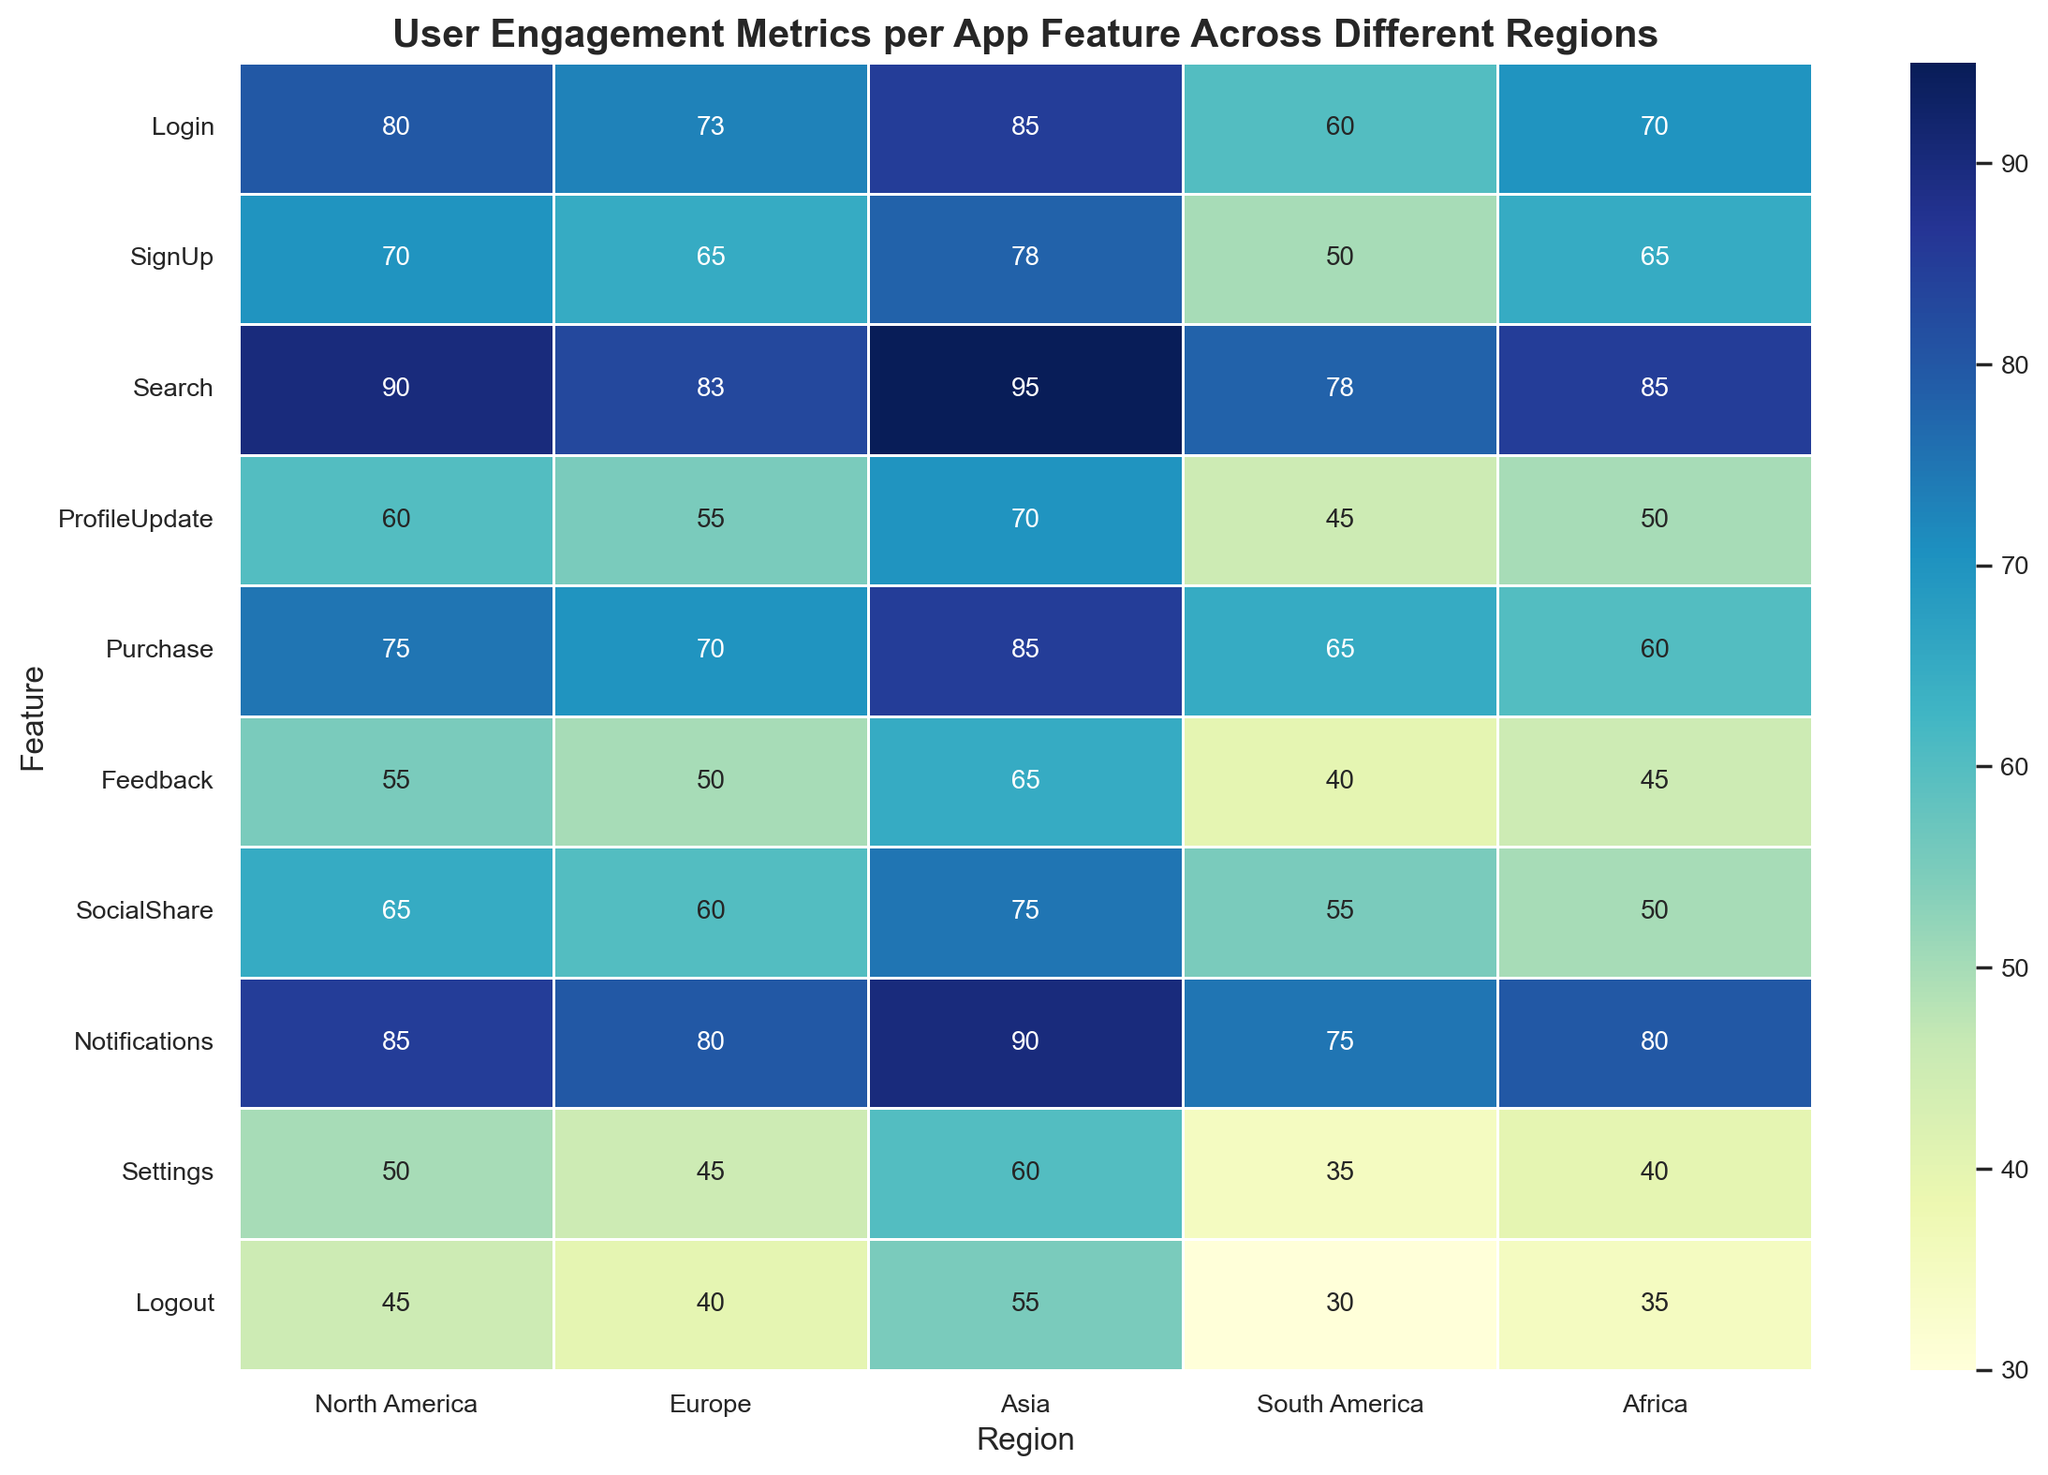Which region has the highest user engagement for the 'Search' feature? The 'Search' feature row should be examined to identify the highest value. The highest number in that row is under 'Asia.'
Answer: Asia Which feature has the lowest engagement in South America? The 'South America' column should be scanned to find the lowest value. The lowest value in that column is in the 'Logout' row.
Answer: Logout What is the average user engagement for the 'Notifications' feature across all regions? Sum the values for the 'Notifications' feature across all regions (85 + 80 + 90 + 75 + 80) and divide by the number of regions (5). The calculation is: (85 + 80 + 90 + 75 + 80) / 5 = 82
Answer: 82 Compare the user engagement for 'ProfileUpdate' between North America and Africa. Which one is higher and by how much? Look at the 'ProfileUpdate' row for both North America and Africa. North America has 60, and Africa has 50. Subtract the smaller from the larger: 60 - 50 = 10. North America is higher.
Answer: North America, 10 Which feature shows the most balanced user engagement across all regions, and what is the range of values for that feature? To find the most balanced feature, the smallest range in values across regions should be identified. By comparing the maximum minus the minimum for each feature, it's 'Logout' (55 - 30 = 25).
Answer: Logout, range is 25 For which feature is the difference in user engagement between North America and South America the greatest? Subtract the South America values from the North America values for each feature and identify the largest difference: 
Login: 20, 
SignUp: 20, 
Search: 12, 
ProfileUpdate: 15, 
Purchase: 10, 
Feedback: 15, 
SocialShare: 10, 
Notifications: 10, 
Settings: 15, 
Logout: 15. 
The greatest difference is for 'Login' and 'SignUp,' both at 20.
Answer: Login and SignUp, 20 Is the user engagement for 'Purchase' in Europe more than that in South America and Africa combined? Check the numbers for 'Purchase' in Europe (70), South America (65), and Africa (60). Summing South America and Africa gives 65 + 60 = 125, which is greater than 70.
Answer: No What is the total user engagement for 'Search' in all regions combined? Add all the values for the 'Search' feature: 90 + 83 + 95 + 78 + 85. The calculation is: 90 + 83 + 95 + 78 + 85 = 431.
Answer: 431 Which region shows the highest overall user engagement across all features, and what is the total engagement? Sum the values for each region and compare: 
North America: 705, 
Europe: 671,
Asia: 798, 
South America: 533, 
Africa: 580. 
The highest total is for Asia.
Answer: Asia, 798 Which feature has the lowest average user engagement across all regions? Calculate the average for each feature and identify the smallest: 
Login: 73.6, 
SignUp: 65.6, 
Search: 86.2, 
ProfileUpdate: 56, 
Purchase: 71, 
Feedback: 51, 
SocialShare: 61, 
Notifications: 82, 
Settings: 46, 
Logout: 41. 
The lowest average is for 'Logout'.
Answer: Logout, 41 